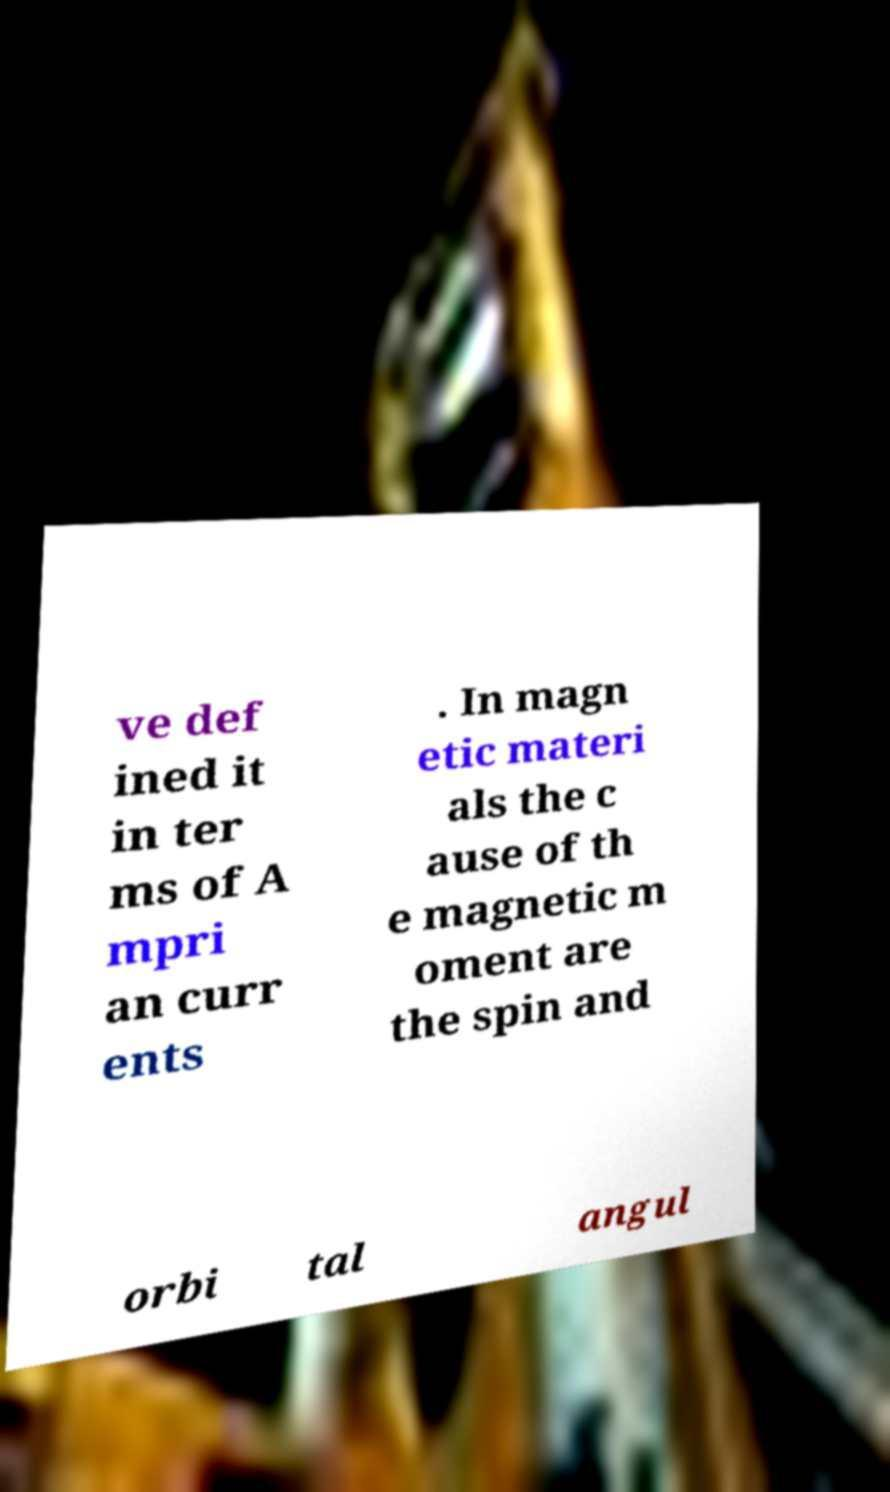I need the written content from this picture converted into text. Can you do that? ve def ined it in ter ms of A mpri an curr ents . In magn etic materi als the c ause of th e magnetic m oment are the spin and orbi tal angul 